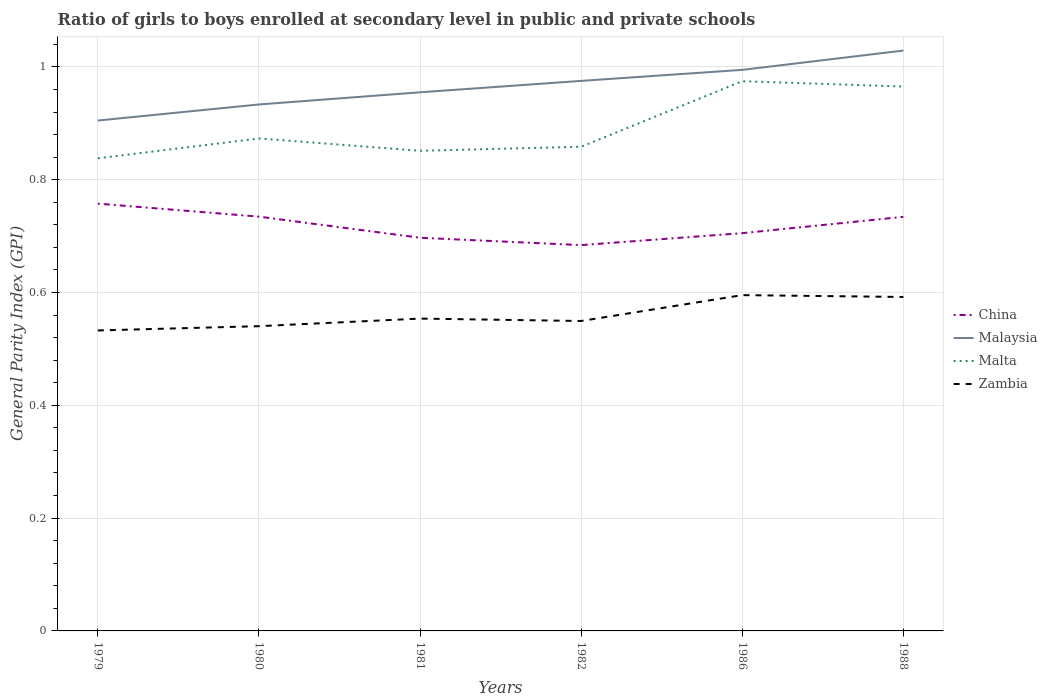How many different coloured lines are there?
Your answer should be compact. 4. Is the number of lines equal to the number of legend labels?
Your answer should be compact. Yes. Across all years, what is the maximum general parity index in Malta?
Offer a very short reply. 0.84. What is the total general parity index in Zambia in the graph?
Offer a terse response. -0.02. What is the difference between the highest and the second highest general parity index in Malta?
Provide a succinct answer. 0.14. What is the difference between the highest and the lowest general parity index in Malta?
Offer a very short reply. 2. How many years are there in the graph?
Offer a terse response. 6. What is the difference between two consecutive major ticks on the Y-axis?
Offer a very short reply. 0.2. Does the graph contain grids?
Your answer should be very brief. Yes. How many legend labels are there?
Make the answer very short. 4. How are the legend labels stacked?
Offer a terse response. Vertical. What is the title of the graph?
Offer a very short reply. Ratio of girls to boys enrolled at secondary level in public and private schools. What is the label or title of the Y-axis?
Ensure brevity in your answer.  General Parity Index (GPI). What is the General Parity Index (GPI) in China in 1979?
Keep it short and to the point. 0.76. What is the General Parity Index (GPI) of Malaysia in 1979?
Ensure brevity in your answer.  0.9. What is the General Parity Index (GPI) in Malta in 1979?
Your response must be concise. 0.84. What is the General Parity Index (GPI) of Zambia in 1979?
Provide a short and direct response. 0.53. What is the General Parity Index (GPI) of China in 1980?
Your answer should be very brief. 0.73. What is the General Parity Index (GPI) in Malaysia in 1980?
Your answer should be very brief. 0.93. What is the General Parity Index (GPI) of Malta in 1980?
Provide a succinct answer. 0.87. What is the General Parity Index (GPI) of Zambia in 1980?
Offer a terse response. 0.54. What is the General Parity Index (GPI) of China in 1981?
Offer a terse response. 0.7. What is the General Parity Index (GPI) of Malaysia in 1981?
Make the answer very short. 0.95. What is the General Parity Index (GPI) of Malta in 1981?
Make the answer very short. 0.85. What is the General Parity Index (GPI) of Zambia in 1981?
Your answer should be very brief. 0.55. What is the General Parity Index (GPI) in China in 1982?
Provide a short and direct response. 0.68. What is the General Parity Index (GPI) of Malaysia in 1982?
Offer a terse response. 0.98. What is the General Parity Index (GPI) in Malta in 1982?
Your answer should be compact. 0.86. What is the General Parity Index (GPI) in Zambia in 1982?
Your answer should be very brief. 0.55. What is the General Parity Index (GPI) in China in 1986?
Give a very brief answer. 0.71. What is the General Parity Index (GPI) of Malaysia in 1986?
Provide a short and direct response. 0.99. What is the General Parity Index (GPI) in Malta in 1986?
Ensure brevity in your answer.  0.97. What is the General Parity Index (GPI) in Zambia in 1986?
Offer a terse response. 0.6. What is the General Parity Index (GPI) of China in 1988?
Your answer should be compact. 0.73. What is the General Parity Index (GPI) of Malaysia in 1988?
Provide a succinct answer. 1.03. What is the General Parity Index (GPI) in Malta in 1988?
Your answer should be very brief. 0.97. What is the General Parity Index (GPI) of Zambia in 1988?
Provide a succinct answer. 0.59. Across all years, what is the maximum General Parity Index (GPI) of China?
Give a very brief answer. 0.76. Across all years, what is the maximum General Parity Index (GPI) in Malaysia?
Offer a terse response. 1.03. Across all years, what is the maximum General Parity Index (GPI) of Malta?
Make the answer very short. 0.97. Across all years, what is the maximum General Parity Index (GPI) in Zambia?
Provide a succinct answer. 0.6. Across all years, what is the minimum General Parity Index (GPI) in China?
Ensure brevity in your answer.  0.68. Across all years, what is the minimum General Parity Index (GPI) in Malaysia?
Keep it short and to the point. 0.9. Across all years, what is the minimum General Parity Index (GPI) in Malta?
Offer a very short reply. 0.84. Across all years, what is the minimum General Parity Index (GPI) of Zambia?
Make the answer very short. 0.53. What is the total General Parity Index (GPI) in China in the graph?
Make the answer very short. 4.31. What is the total General Parity Index (GPI) in Malaysia in the graph?
Ensure brevity in your answer.  5.79. What is the total General Parity Index (GPI) of Malta in the graph?
Give a very brief answer. 5.36. What is the total General Parity Index (GPI) in Zambia in the graph?
Your response must be concise. 3.36. What is the difference between the General Parity Index (GPI) of China in 1979 and that in 1980?
Provide a succinct answer. 0.02. What is the difference between the General Parity Index (GPI) in Malaysia in 1979 and that in 1980?
Your response must be concise. -0.03. What is the difference between the General Parity Index (GPI) in Malta in 1979 and that in 1980?
Give a very brief answer. -0.04. What is the difference between the General Parity Index (GPI) of Zambia in 1979 and that in 1980?
Provide a succinct answer. -0.01. What is the difference between the General Parity Index (GPI) of China in 1979 and that in 1981?
Your response must be concise. 0.06. What is the difference between the General Parity Index (GPI) of Malaysia in 1979 and that in 1981?
Give a very brief answer. -0.05. What is the difference between the General Parity Index (GPI) in Malta in 1979 and that in 1981?
Offer a terse response. -0.01. What is the difference between the General Parity Index (GPI) in Zambia in 1979 and that in 1981?
Provide a succinct answer. -0.02. What is the difference between the General Parity Index (GPI) of China in 1979 and that in 1982?
Make the answer very short. 0.07. What is the difference between the General Parity Index (GPI) of Malaysia in 1979 and that in 1982?
Give a very brief answer. -0.07. What is the difference between the General Parity Index (GPI) of Malta in 1979 and that in 1982?
Provide a succinct answer. -0.02. What is the difference between the General Parity Index (GPI) of Zambia in 1979 and that in 1982?
Offer a terse response. -0.02. What is the difference between the General Parity Index (GPI) of China in 1979 and that in 1986?
Your response must be concise. 0.05. What is the difference between the General Parity Index (GPI) in Malaysia in 1979 and that in 1986?
Make the answer very short. -0.09. What is the difference between the General Parity Index (GPI) in Malta in 1979 and that in 1986?
Offer a terse response. -0.14. What is the difference between the General Parity Index (GPI) of Zambia in 1979 and that in 1986?
Offer a very short reply. -0.06. What is the difference between the General Parity Index (GPI) in China in 1979 and that in 1988?
Offer a terse response. 0.02. What is the difference between the General Parity Index (GPI) in Malaysia in 1979 and that in 1988?
Offer a terse response. -0.12. What is the difference between the General Parity Index (GPI) of Malta in 1979 and that in 1988?
Your answer should be very brief. -0.13. What is the difference between the General Parity Index (GPI) in Zambia in 1979 and that in 1988?
Offer a terse response. -0.06. What is the difference between the General Parity Index (GPI) in China in 1980 and that in 1981?
Your answer should be very brief. 0.04. What is the difference between the General Parity Index (GPI) in Malaysia in 1980 and that in 1981?
Your response must be concise. -0.02. What is the difference between the General Parity Index (GPI) in Malta in 1980 and that in 1981?
Offer a very short reply. 0.02. What is the difference between the General Parity Index (GPI) in Zambia in 1980 and that in 1981?
Your response must be concise. -0.01. What is the difference between the General Parity Index (GPI) in China in 1980 and that in 1982?
Keep it short and to the point. 0.05. What is the difference between the General Parity Index (GPI) of Malaysia in 1980 and that in 1982?
Your answer should be very brief. -0.04. What is the difference between the General Parity Index (GPI) in Malta in 1980 and that in 1982?
Give a very brief answer. 0.01. What is the difference between the General Parity Index (GPI) of Zambia in 1980 and that in 1982?
Offer a very short reply. -0.01. What is the difference between the General Parity Index (GPI) of China in 1980 and that in 1986?
Give a very brief answer. 0.03. What is the difference between the General Parity Index (GPI) of Malaysia in 1980 and that in 1986?
Provide a short and direct response. -0.06. What is the difference between the General Parity Index (GPI) of Malta in 1980 and that in 1986?
Offer a terse response. -0.1. What is the difference between the General Parity Index (GPI) of Zambia in 1980 and that in 1986?
Keep it short and to the point. -0.06. What is the difference between the General Parity Index (GPI) in Malaysia in 1980 and that in 1988?
Provide a short and direct response. -0.1. What is the difference between the General Parity Index (GPI) of Malta in 1980 and that in 1988?
Your answer should be very brief. -0.09. What is the difference between the General Parity Index (GPI) of Zambia in 1980 and that in 1988?
Your answer should be compact. -0.05. What is the difference between the General Parity Index (GPI) of China in 1981 and that in 1982?
Give a very brief answer. 0.01. What is the difference between the General Parity Index (GPI) in Malaysia in 1981 and that in 1982?
Your response must be concise. -0.02. What is the difference between the General Parity Index (GPI) of Malta in 1981 and that in 1982?
Your answer should be very brief. -0.01. What is the difference between the General Parity Index (GPI) of Zambia in 1981 and that in 1982?
Offer a terse response. 0. What is the difference between the General Parity Index (GPI) of China in 1981 and that in 1986?
Offer a terse response. -0.01. What is the difference between the General Parity Index (GPI) of Malaysia in 1981 and that in 1986?
Offer a very short reply. -0.04. What is the difference between the General Parity Index (GPI) in Malta in 1981 and that in 1986?
Keep it short and to the point. -0.12. What is the difference between the General Parity Index (GPI) in Zambia in 1981 and that in 1986?
Offer a terse response. -0.04. What is the difference between the General Parity Index (GPI) in China in 1981 and that in 1988?
Ensure brevity in your answer.  -0.04. What is the difference between the General Parity Index (GPI) of Malaysia in 1981 and that in 1988?
Make the answer very short. -0.07. What is the difference between the General Parity Index (GPI) of Malta in 1981 and that in 1988?
Offer a very short reply. -0.11. What is the difference between the General Parity Index (GPI) in Zambia in 1981 and that in 1988?
Your answer should be compact. -0.04. What is the difference between the General Parity Index (GPI) of China in 1982 and that in 1986?
Provide a short and direct response. -0.02. What is the difference between the General Parity Index (GPI) of Malaysia in 1982 and that in 1986?
Provide a succinct answer. -0.02. What is the difference between the General Parity Index (GPI) of Malta in 1982 and that in 1986?
Keep it short and to the point. -0.12. What is the difference between the General Parity Index (GPI) in Zambia in 1982 and that in 1986?
Your answer should be very brief. -0.05. What is the difference between the General Parity Index (GPI) of China in 1982 and that in 1988?
Your answer should be compact. -0.05. What is the difference between the General Parity Index (GPI) of Malaysia in 1982 and that in 1988?
Keep it short and to the point. -0.05. What is the difference between the General Parity Index (GPI) of Malta in 1982 and that in 1988?
Your answer should be compact. -0.11. What is the difference between the General Parity Index (GPI) in Zambia in 1982 and that in 1988?
Offer a terse response. -0.04. What is the difference between the General Parity Index (GPI) in China in 1986 and that in 1988?
Make the answer very short. -0.03. What is the difference between the General Parity Index (GPI) of Malaysia in 1986 and that in 1988?
Keep it short and to the point. -0.03. What is the difference between the General Parity Index (GPI) of Malta in 1986 and that in 1988?
Your answer should be compact. 0.01. What is the difference between the General Parity Index (GPI) in Zambia in 1986 and that in 1988?
Offer a terse response. 0. What is the difference between the General Parity Index (GPI) of China in 1979 and the General Parity Index (GPI) of Malaysia in 1980?
Your response must be concise. -0.18. What is the difference between the General Parity Index (GPI) of China in 1979 and the General Parity Index (GPI) of Malta in 1980?
Offer a terse response. -0.12. What is the difference between the General Parity Index (GPI) in China in 1979 and the General Parity Index (GPI) in Zambia in 1980?
Offer a terse response. 0.22. What is the difference between the General Parity Index (GPI) of Malaysia in 1979 and the General Parity Index (GPI) of Malta in 1980?
Make the answer very short. 0.03. What is the difference between the General Parity Index (GPI) in Malaysia in 1979 and the General Parity Index (GPI) in Zambia in 1980?
Offer a terse response. 0.36. What is the difference between the General Parity Index (GPI) of Malta in 1979 and the General Parity Index (GPI) of Zambia in 1980?
Provide a succinct answer. 0.3. What is the difference between the General Parity Index (GPI) in China in 1979 and the General Parity Index (GPI) in Malaysia in 1981?
Give a very brief answer. -0.2. What is the difference between the General Parity Index (GPI) of China in 1979 and the General Parity Index (GPI) of Malta in 1981?
Your answer should be compact. -0.09. What is the difference between the General Parity Index (GPI) in China in 1979 and the General Parity Index (GPI) in Zambia in 1981?
Your response must be concise. 0.2. What is the difference between the General Parity Index (GPI) of Malaysia in 1979 and the General Parity Index (GPI) of Malta in 1981?
Offer a terse response. 0.05. What is the difference between the General Parity Index (GPI) in Malaysia in 1979 and the General Parity Index (GPI) in Zambia in 1981?
Your answer should be very brief. 0.35. What is the difference between the General Parity Index (GPI) in Malta in 1979 and the General Parity Index (GPI) in Zambia in 1981?
Your response must be concise. 0.28. What is the difference between the General Parity Index (GPI) in China in 1979 and the General Parity Index (GPI) in Malaysia in 1982?
Offer a terse response. -0.22. What is the difference between the General Parity Index (GPI) of China in 1979 and the General Parity Index (GPI) of Malta in 1982?
Provide a succinct answer. -0.1. What is the difference between the General Parity Index (GPI) in China in 1979 and the General Parity Index (GPI) in Zambia in 1982?
Ensure brevity in your answer.  0.21. What is the difference between the General Parity Index (GPI) of Malaysia in 1979 and the General Parity Index (GPI) of Malta in 1982?
Make the answer very short. 0.05. What is the difference between the General Parity Index (GPI) of Malaysia in 1979 and the General Parity Index (GPI) of Zambia in 1982?
Your answer should be very brief. 0.36. What is the difference between the General Parity Index (GPI) in Malta in 1979 and the General Parity Index (GPI) in Zambia in 1982?
Your response must be concise. 0.29. What is the difference between the General Parity Index (GPI) of China in 1979 and the General Parity Index (GPI) of Malaysia in 1986?
Give a very brief answer. -0.24. What is the difference between the General Parity Index (GPI) in China in 1979 and the General Parity Index (GPI) in Malta in 1986?
Your response must be concise. -0.22. What is the difference between the General Parity Index (GPI) in China in 1979 and the General Parity Index (GPI) in Zambia in 1986?
Ensure brevity in your answer.  0.16. What is the difference between the General Parity Index (GPI) in Malaysia in 1979 and the General Parity Index (GPI) in Malta in 1986?
Give a very brief answer. -0.07. What is the difference between the General Parity Index (GPI) of Malaysia in 1979 and the General Parity Index (GPI) of Zambia in 1986?
Offer a terse response. 0.31. What is the difference between the General Parity Index (GPI) in Malta in 1979 and the General Parity Index (GPI) in Zambia in 1986?
Offer a very short reply. 0.24. What is the difference between the General Parity Index (GPI) of China in 1979 and the General Parity Index (GPI) of Malaysia in 1988?
Provide a short and direct response. -0.27. What is the difference between the General Parity Index (GPI) in China in 1979 and the General Parity Index (GPI) in Malta in 1988?
Provide a short and direct response. -0.21. What is the difference between the General Parity Index (GPI) in China in 1979 and the General Parity Index (GPI) in Zambia in 1988?
Your answer should be very brief. 0.17. What is the difference between the General Parity Index (GPI) in Malaysia in 1979 and the General Parity Index (GPI) in Malta in 1988?
Make the answer very short. -0.06. What is the difference between the General Parity Index (GPI) in Malaysia in 1979 and the General Parity Index (GPI) in Zambia in 1988?
Ensure brevity in your answer.  0.31. What is the difference between the General Parity Index (GPI) of Malta in 1979 and the General Parity Index (GPI) of Zambia in 1988?
Give a very brief answer. 0.25. What is the difference between the General Parity Index (GPI) in China in 1980 and the General Parity Index (GPI) in Malaysia in 1981?
Ensure brevity in your answer.  -0.22. What is the difference between the General Parity Index (GPI) in China in 1980 and the General Parity Index (GPI) in Malta in 1981?
Offer a very short reply. -0.12. What is the difference between the General Parity Index (GPI) of China in 1980 and the General Parity Index (GPI) of Zambia in 1981?
Keep it short and to the point. 0.18. What is the difference between the General Parity Index (GPI) of Malaysia in 1980 and the General Parity Index (GPI) of Malta in 1981?
Your answer should be very brief. 0.08. What is the difference between the General Parity Index (GPI) in Malaysia in 1980 and the General Parity Index (GPI) in Zambia in 1981?
Provide a succinct answer. 0.38. What is the difference between the General Parity Index (GPI) of Malta in 1980 and the General Parity Index (GPI) of Zambia in 1981?
Offer a terse response. 0.32. What is the difference between the General Parity Index (GPI) in China in 1980 and the General Parity Index (GPI) in Malaysia in 1982?
Keep it short and to the point. -0.24. What is the difference between the General Parity Index (GPI) in China in 1980 and the General Parity Index (GPI) in Malta in 1982?
Offer a very short reply. -0.12. What is the difference between the General Parity Index (GPI) in China in 1980 and the General Parity Index (GPI) in Zambia in 1982?
Your response must be concise. 0.18. What is the difference between the General Parity Index (GPI) of Malaysia in 1980 and the General Parity Index (GPI) of Malta in 1982?
Your answer should be compact. 0.07. What is the difference between the General Parity Index (GPI) in Malaysia in 1980 and the General Parity Index (GPI) in Zambia in 1982?
Make the answer very short. 0.38. What is the difference between the General Parity Index (GPI) of Malta in 1980 and the General Parity Index (GPI) of Zambia in 1982?
Provide a short and direct response. 0.32. What is the difference between the General Parity Index (GPI) of China in 1980 and the General Parity Index (GPI) of Malaysia in 1986?
Provide a succinct answer. -0.26. What is the difference between the General Parity Index (GPI) of China in 1980 and the General Parity Index (GPI) of Malta in 1986?
Offer a terse response. -0.24. What is the difference between the General Parity Index (GPI) in China in 1980 and the General Parity Index (GPI) in Zambia in 1986?
Your answer should be very brief. 0.14. What is the difference between the General Parity Index (GPI) of Malaysia in 1980 and the General Parity Index (GPI) of Malta in 1986?
Keep it short and to the point. -0.04. What is the difference between the General Parity Index (GPI) of Malaysia in 1980 and the General Parity Index (GPI) of Zambia in 1986?
Provide a succinct answer. 0.34. What is the difference between the General Parity Index (GPI) in Malta in 1980 and the General Parity Index (GPI) in Zambia in 1986?
Provide a succinct answer. 0.28. What is the difference between the General Parity Index (GPI) of China in 1980 and the General Parity Index (GPI) of Malaysia in 1988?
Keep it short and to the point. -0.29. What is the difference between the General Parity Index (GPI) of China in 1980 and the General Parity Index (GPI) of Malta in 1988?
Your answer should be very brief. -0.23. What is the difference between the General Parity Index (GPI) of China in 1980 and the General Parity Index (GPI) of Zambia in 1988?
Your answer should be compact. 0.14. What is the difference between the General Parity Index (GPI) of Malaysia in 1980 and the General Parity Index (GPI) of Malta in 1988?
Offer a terse response. -0.03. What is the difference between the General Parity Index (GPI) in Malaysia in 1980 and the General Parity Index (GPI) in Zambia in 1988?
Provide a succinct answer. 0.34. What is the difference between the General Parity Index (GPI) in Malta in 1980 and the General Parity Index (GPI) in Zambia in 1988?
Provide a succinct answer. 0.28. What is the difference between the General Parity Index (GPI) in China in 1981 and the General Parity Index (GPI) in Malaysia in 1982?
Offer a very short reply. -0.28. What is the difference between the General Parity Index (GPI) in China in 1981 and the General Parity Index (GPI) in Malta in 1982?
Offer a terse response. -0.16. What is the difference between the General Parity Index (GPI) in China in 1981 and the General Parity Index (GPI) in Zambia in 1982?
Offer a very short reply. 0.15. What is the difference between the General Parity Index (GPI) of Malaysia in 1981 and the General Parity Index (GPI) of Malta in 1982?
Make the answer very short. 0.1. What is the difference between the General Parity Index (GPI) of Malaysia in 1981 and the General Parity Index (GPI) of Zambia in 1982?
Provide a succinct answer. 0.41. What is the difference between the General Parity Index (GPI) of Malta in 1981 and the General Parity Index (GPI) of Zambia in 1982?
Your answer should be compact. 0.3. What is the difference between the General Parity Index (GPI) in China in 1981 and the General Parity Index (GPI) in Malaysia in 1986?
Keep it short and to the point. -0.3. What is the difference between the General Parity Index (GPI) of China in 1981 and the General Parity Index (GPI) of Malta in 1986?
Your answer should be very brief. -0.28. What is the difference between the General Parity Index (GPI) of China in 1981 and the General Parity Index (GPI) of Zambia in 1986?
Your response must be concise. 0.1. What is the difference between the General Parity Index (GPI) in Malaysia in 1981 and the General Parity Index (GPI) in Malta in 1986?
Ensure brevity in your answer.  -0.02. What is the difference between the General Parity Index (GPI) in Malaysia in 1981 and the General Parity Index (GPI) in Zambia in 1986?
Your response must be concise. 0.36. What is the difference between the General Parity Index (GPI) in Malta in 1981 and the General Parity Index (GPI) in Zambia in 1986?
Offer a terse response. 0.26. What is the difference between the General Parity Index (GPI) in China in 1981 and the General Parity Index (GPI) in Malaysia in 1988?
Ensure brevity in your answer.  -0.33. What is the difference between the General Parity Index (GPI) of China in 1981 and the General Parity Index (GPI) of Malta in 1988?
Provide a short and direct response. -0.27. What is the difference between the General Parity Index (GPI) of China in 1981 and the General Parity Index (GPI) of Zambia in 1988?
Your response must be concise. 0.1. What is the difference between the General Parity Index (GPI) in Malaysia in 1981 and the General Parity Index (GPI) in Malta in 1988?
Provide a succinct answer. -0.01. What is the difference between the General Parity Index (GPI) of Malaysia in 1981 and the General Parity Index (GPI) of Zambia in 1988?
Your answer should be very brief. 0.36. What is the difference between the General Parity Index (GPI) of Malta in 1981 and the General Parity Index (GPI) of Zambia in 1988?
Provide a succinct answer. 0.26. What is the difference between the General Parity Index (GPI) in China in 1982 and the General Parity Index (GPI) in Malaysia in 1986?
Ensure brevity in your answer.  -0.31. What is the difference between the General Parity Index (GPI) in China in 1982 and the General Parity Index (GPI) in Malta in 1986?
Make the answer very short. -0.29. What is the difference between the General Parity Index (GPI) in China in 1982 and the General Parity Index (GPI) in Zambia in 1986?
Keep it short and to the point. 0.09. What is the difference between the General Parity Index (GPI) in Malaysia in 1982 and the General Parity Index (GPI) in Malta in 1986?
Offer a terse response. 0. What is the difference between the General Parity Index (GPI) in Malaysia in 1982 and the General Parity Index (GPI) in Zambia in 1986?
Your answer should be compact. 0.38. What is the difference between the General Parity Index (GPI) of Malta in 1982 and the General Parity Index (GPI) of Zambia in 1986?
Offer a terse response. 0.26. What is the difference between the General Parity Index (GPI) of China in 1982 and the General Parity Index (GPI) of Malaysia in 1988?
Your answer should be very brief. -0.34. What is the difference between the General Parity Index (GPI) of China in 1982 and the General Parity Index (GPI) of Malta in 1988?
Keep it short and to the point. -0.28. What is the difference between the General Parity Index (GPI) of China in 1982 and the General Parity Index (GPI) of Zambia in 1988?
Your response must be concise. 0.09. What is the difference between the General Parity Index (GPI) of Malaysia in 1982 and the General Parity Index (GPI) of Malta in 1988?
Your answer should be very brief. 0.01. What is the difference between the General Parity Index (GPI) of Malaysia in 1982 and the General Parity Index (GPI) of Zambia in 1988?
Your answer should be very brief. 0.38. What is the difference between the General Parity Index (GPI) in Malta in 1982 and the General Parity Index (GPI) in Zambia in 1988?
Keep it short and to the point. 0.27. What is the difference between the General Parity Index (GPI) in China in 1986 and the General Parity Index (GPI) in Malaysia in 1988?
Your answer should be compact. -0.32. What is the difference between the General Parity Index (GPI) of China in 1986 and the General Parity Index (GPI) of Malta in 1988?
Provide a succinct answer. -0.26. What is the difference between the General Parity Index (GPI) of China in 1986 and the General Parity Index (GPI) of Zambia in 1988?
Offer a terse response. 0.11. What is the difference between the General Parity Index (GPI) of Malaysia in 1986 and the General Parity Index (GPI) of Malta in 1988?
Ensure brevity in your answer.  0.03. What is the difference between the General Parity Index (GPI) in Malaysia in 1986 and the General Parity Index (GPI) in Zambia in 1988?
Provide a succinct answer. 0.4. What is the difference between the General Parity Index (GPI) of Malta in 1986 and the General Parity Index (GPI) of Zambia in 1988?
Give a very brief answer. 0.38. What is the average General Parity Index (GPI) in China per year?
Provide a short and direct response. 0.72. What is the average General Parity Index (GPI) in Malaysia per year?
Provide a succinct answer. 0.97. What is the average General Parity Index (GPI) of Malta per year?
Offer a very short reply. 0.89. What is the average General Parity Index (GPI) of Zambia per year?
Make the answer very short. 0.56. In the year 1979, what is the difference between the General Parity Index (GPI) in China and General Parity Index (GPI) in Malaysia?
Give a very brief answer. -0.15. In the year 1979, what is the difference between the General Parity Index (GPI) of China and General Parity Index (GPI) of Malta?
Your answer should be compact. -0.08. In the year 1979, what is the difference between the General Parity Index (GPI) of China and General Parity Index (GPI) of Zambia?
Your answer should be compact. 0.22. In the year 1979, what is the difference between the General Parity Index (GPI) of Malaysia and General Parity Index (GPI) of Malta?
Your answer should be compact. 0.07. In the year 1979, what is the difference between the General Parity Index (GPI) in Malaysia and General Parity Index (GPI) in Zambia?
Give a very brief answer. 0.37. In the year 1979, what is the difference between the General Parity Index (GPI) of Malta and General Parity Index (GPI) of Zambia?
Give a very brief answer. 0.31. In the year 1980, what is the difference between the General Parity Index (GPI) in China and General Parity Index (GPI) in Malaysia?
Offer a very short reply. -0.2. In the year 1980, what is the difference between the General Parity Index (GPI) in China and General Parity Index (GPI) in Malta?
Offer a terse response. -0.14. In the year 1980, what is the difference between the General Parity Index (GPI) of China and General Parity Index (GPI) of Zambia?
Make the answer very short. 0.19. In the year 1980, what is the difference between the General Parity Index (GPI) of Malaysia and General Parity Index (GPI) of Malta?
Make the answer very short. 0.06. In the year 1980, what is the difference between the General Parity Index (GPI) of Malaysia and General Parity Index (GPI) of Zambia?
Your response must be concise. 0.39. In the year 1980, what is the difference between the General Parity Index (GPI) in Malta and General Parity Index (GPI) in Zambia?
Make the answer very short. 0.33. In the year 1981, what is the difference between the General Parity Index (GPI) of China and General Parity Index (GPI) of Malaysia?
Offer a terse response. -0.26. In the year 1981, what is the difference between the General Parity Index (GPI) of China and General Parity Index (GPI) of Malta?
Ensure brevity in your answer.  -0.15. In the year 1981, what is the difference between the General Parity Index (GPI) in China and General Parity Index (GPI) in Zambia?
Provide a succinct answer. 0.14. In the year 1981, what is the difference between the General Parity Index (GPI) of Malaysia and General Parity Index (GPI) of Malta?
Offer a terse response. 0.1. In the year 1981, what is the difference between the General Parity Index (GPI) in Malaysia and General Parity Index (GPI) in Zambia?
Your response must be concise. 0.4. In the year 1981, what is the difference between the General Parity Index (GPI) of Malta and General Parity Index (GPI) of Zambia?
Ensure brevity in your answer.  0.3. In the year 1982, what is the difference between the General Parity Index (GPI) of China and General Parity Index (GPI) of Malaysia?
Ensure brevity in your answer.  -0.29. In the year 1982, what is the difference between the General Parity Index (GPI) of China and General Parity Index (GPI) of Malta?
Ensure brevity in your answer.  -0.17. In the year 1982, what is the difference between the General Parity Index (GPI) of China and General Parity Index (GPI) of Zambia?
Your answer should be very brief. 0.13. In the year 1982, what is the difference between the General Parity Index (GPI) in Malaysia and General Parity Index (GPI) in Malta?
Provide a succinct answer. 0.12. In the year 1982, what is the difference between the General Parity Index (GPI) in Malaysia and General Parity Index (GPI) in Zambia?
Provide a short and direct response. 0.43. In the year 1982, what is the difference between the General Parity Index (GPI) of Malta and General Parity Index (GPI) of Zambia?
Your answer should be compact. 0.31. In the year 1986, what is the difference between the General Parity Index (GPI) of China and General Parity Index (GPI) of Malaysia?
Keep it short and to the point. -0.29. In the year 1986, what is the difference between the General Parity Index (GPI) in China and General Parity Index (GPI) in Malta?
Offer a very short reply. -0.27. In the year 1986, what is the difference between the General Parity Index (GPI) of China and General Parity Index (GPI) of Zambia?
Provide a succinct answer. 0.11. In the year 1986, what is the difference between the General Parity Index (GPI) of Malaysia and General Parity Index (GPI) of Malta?
Provide a short and direct response. 0.02. In the year 1986, what is the difference between the General Parity Index (GPI) of Malaysia and General Parity Index (GPI) of Zambia?
Your answer should be very brief. 0.4. In the year 1986, what is the difference between the General Parity Index (GPI) of Malta and General Parity Index (GPI) of Zambia?
Offer a terse response. 0.38. In the year 1988, what is the difference between the General Parity Index (GPI) in China and General Parity Index (GPI) in Malaysia?
Make the answer very short. -0.29. In the year 1988, what is the difference between the General Parity Index (GPI) of China and General Parity Index (GPI) of Malta?
Ensure brevity in your answer.  -0.23. In the year 1988, what is the difference between the General Parity Index (GPI) in China and General Parity Index (GPI) in Zambia?
Give a very brief answer. 0.14. In the year 1988, what is the difference between the General Parity Index (GPI) of Malaysia and General Parity Index (GPI) of Malta?
Provide a succinct answer. 0.06. In the year 1988, what is the difference between the General Parity Index (GPI) of Malaysia and General Parity Index (GPI) of Zambia?
Make the answer very short. 0.44. In the year 1988, what is the difference between the General Parity Index (GPI) of Malta and General Parity Index (GPI) of Zambia?
Your answer should be compact. 0.37. What is the ratio of the General Parity Index (GPI) of China in 1979 to that in 1980?
Ensure brevity in your answer.  1.03. What is the ratio of the General Parity Index (GPI) of Malaysia in 1979 to that in 1980?
Your answer should be very brief. 0.97. What is the ratio of the General Parity Index (GPI) of Malta in 1979 to that in 1980?
Give a very brief answer. 0.96. What is the ratio of the General Parity Index (GPI) in China in 1979 to that in 1981?
Your response must be concise. 1.09. What is the ratio of the General Parity Index (GPI) in Malaysia in 1979 to that in 1981?
Your response must be concise. 0.95. What is the ratio of the General Parity Index (GPI) in Malta in 1979 to that in 1981?
Offer a very short reply. 0.98. What is the ratio of the General Parity Index (GPI) of Zambia in 1979 to that in 1981?
Offer a very short reply. 0.96. What is the ratio of the General Parity Index (GPI) in China in 1979 to that in 1982?
Your answer should be compact. 1.11. What is the ratio of the General Parity Index (GPI) of Malaysia in 1979 to that in 1982?
Provide a succinct answer. 0.93. What is the ratio of the General Parity Index (GPI) in Malta in 1979 to that in 1982?
Make the answer very short. 0.98. What is the ratio of the General Parity Index (GPI) of Zambia in 1979 to that in 1982?
Ensure brevity in your answer.  0.97. What is the ratio of the General Parity Index (GPI) of China in 1979 to that in 1986?
Offer a very short reply. 1.07. What is the ratio of the General Parity Index (GPI) of Malaysia in 1979 to that in 1986?
Offer a terse response. 0.91. What is the ratio of the General Parity Index (GPI) of Malta in 1979 to that in 1986?
Your answer should be very brief. 0.86. What is the ratio of the General Parity Index (GPI) of Zambia in 1979 to that in 1986?
Offer a terse response. 0.89. What is the ratio of the General Parity Index (GPI) of China in 1979 to that in 1988?
Give a very brief answer. 1.03. What is the ratio of the General Parity Index (GPI) in Malaysia in 1979 to that in 1988?
Your response must be concise. 0.88. What is the ratio of the General Parity Index (GPI) in Malta in 1979 to that in 1988?
Your answer should be compact. 0.87. What is the ratio of the General Parity Index (GPI) of Zambia in 1979 to that in 1988?
Offer a terse response. 0.9. What is the ratio of the General Parity Index (GPI) of China in 1980 to that in 1981?
Your response must be concise. 1.05. What is the ratio of the General Parity Index (GPI) of Malaysia in 1980 to that in 1981?
Make the answer very short. 0.98. What is the ratio of the General Parity Index (GPI) in Malta in 1980 to that in 1981?
Your response must be concise. 1.03. What is the ratio of the General Parity Index (GPI) in Zambia in 1980 to that in 1981?
Your response must be concise. 0.98. What is the ratio of the General Parity Index (GPI) of China in 1980 to that in 1982?
Your answer should be very brief. 1.07. What is the ratio of the General Parity Index (GPI) of Malaysia in 1980 to that in 1982?
Ensure brevity in your answer.  0.96. What is the ratio of the General Parity Index (GPI) in Malta in 1980 to that in 1982?
Offer a terse response. 1.02. What is the ratio of the General Parity Index (GPI) of Zambia in 1980 to that in 1982?
Provide a succinct answer. 0.98. What is the ratio of the General Parity Index (GPI) of China in 1980 to that in 1986?
Ensure brevity in your answer.  1.04. What is the ratio of the General Parity Index (GPI) of Malaysia in 1980 to that in 1986?
Provide a succinct answer. 0.94. What is the ratio of the General Parity Index (GPI) in Malta in 1980 to that in 1986?
Offer a terse response. 0.9. What is the ratio of the General Parity Index (GPI) in Zambia in 1980 to that in 1986?
Make the answer very short. 0.91. What is the ratio of the General Parity Index (GPI) in China in 1980 to that in 1988?
Offer a terse response. 1. What is the ratio of the General Parity Index (GPI) of Malaysia in 1980 to that in 1988?
Offer a very short reply. 0.91. What is the ratio of the General Parity Index (GPI) in Malta in 1980 to that in 1988?
Provide a succinct answer. 0.9. What is the ratio of the General Parity Index (GPI) in Zambia in 1980 to that in 1988?
Make the answer very short. 0.91. What is the ratio of the General Parity Index (GPI) of China in 1981 to that in 1982?
Offer a very short reply. 1.02. What is the ratio of the General Parity Index (GPI) of Malaysia in 1981 to that in 1982?
Ensure brevity in your answer.  0.98. What is the ratio of the General Parity Index (GPI) of Malta in 1981 to that in 1982?
Your answer should be compact. 0.99. What is the ratio of the General Parity Index (GPI) in Zambia in 1981 to that in 1982?
Ensure brevity in your answer.  1.01. What is the ratio of the General Parity Index (GPI) of China in 1981 to that in 1986?
Give a very brief answer. 0.99. What is the ratio of the General Parity Index (GPI) in Malaysia in 1981 to that in 1986?
Provide a succinct answer. 0.96. What is the ratio of the General Parity Index (GPI) in Malta in 1981 to that in 1986?
Provide a short and direct response. 0.87. What is the ratio of the General Parity Index (GPI) of Zambia in 1981 to that in 1986?
Ensure brevity in your answer.  0.93. What is the ratio of the General Parity Index (GPI) in China in 1981 to that in 1988?
Give a very brief answer. 0.95. What is the ratio of the General Parity Index (GPI) of Malaysia in 1981 to that in 1988?
Provide a succinct answer. 0.93. What is the ratio of the General Parity Index (GPI) in Malta in 1981 to that in 1988?
Your response must be concise. 0.88. What is the ratio of the General Parity Index (GPI) of Zambia in 1981 to that in 1988?
Make the answer very short. 0.94. What is the ratio of the General Parity Index (GPI) in Malaysia in 1982 to that in 1986?
Your answer should be compact. 0.98. What is the ratio of the General Parity Index (GPI) in Malta in 1982 to that in 1986?
Provide a short and direct response. 0.88. What is the ratio of the General Parity Index (GPI) of Zambia in 1982 to that in 1986?
Your answer should be very brief. 0.92. What is the ratio of the General Parity Index (GPI) in China in 1982 to that in 1988?
Offer a very short reply. 0.93. What is the ratio of the General Parity Index (GPI) of Malaysia in 1982 to that in 1988?
Provide a short and direct response. 0.95. What is the ratio of the General Parity Index (GPI) in Malta in 1982 to that in 1988?
Make the answer very short. 0.89. What is the ratio of the General Parity Index (GPI) in Zambia in 1982 to that in 1988?
Your response must be concise. 0.93. What is the ratio of the General Parity Index (GPI) in China in 1986 to that in 1988?
Give a very brief answer. 0.96. What is the ratio of the General Parity Index (GPI) in Malaysia in 1986 to that in 1988?
Give a very brief answer. 0.97. What is the ratio of the General Parity Index (GPI) in Malta in 1986 to that in 1988?
Make the answer very short. 1.01. What is the ratio of the General Parity Index (GPI) in Zambia in 1986 to that in 1988?
Give a very brief answer. 1.01. What is the difference between the highest and the second highest General Parity Index (GPI) of China?
Offer a very short reply. 0.02. What is the difference between the highest and the second highest General Parity Index (GPI) in Malaysia?
Keep it short and to the point. 0.03. What is the difference between the highest and the second highest General Parity Index (GPI) of Malta?
Keep it short and to the point. 0.01. What is the difference between the highest and the second highest General Parity Index (GPI) of Zambia?
Your answer should be very brief. 0. What is the difference between the highest and the lowest General Parity Index (GPI) of China?
Offer a terse response. 0.07. What is the difference between the highest and the lowest General Parity Index (GPI) in Malaysia?
Offer a very short reply. 0.12. What is the difference between the highest and the lowest General Parity Index (GPI) of Malta?
Provide a succinct answer. 0.14. What is the difference between the highest and the lowest General Parity Index (GPI) of Zambia?
Give a very brief answer. 0.06. 